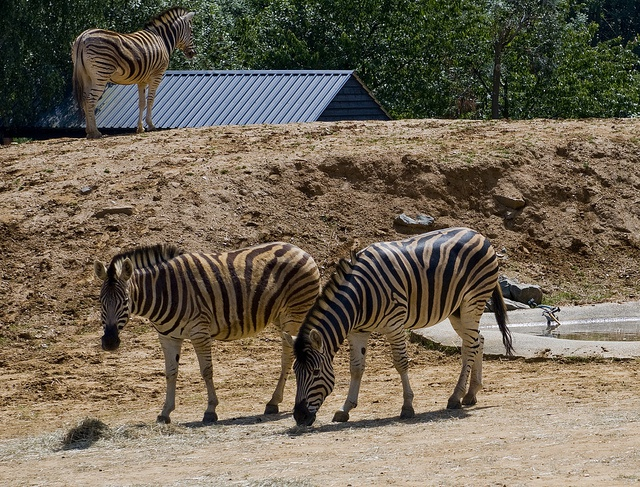Describe the objects in this image and their specific colors. I can see zebra in black and gray tones, zebra in black, maroon, and gray tones, and zebra in black and gray tones in this image. 